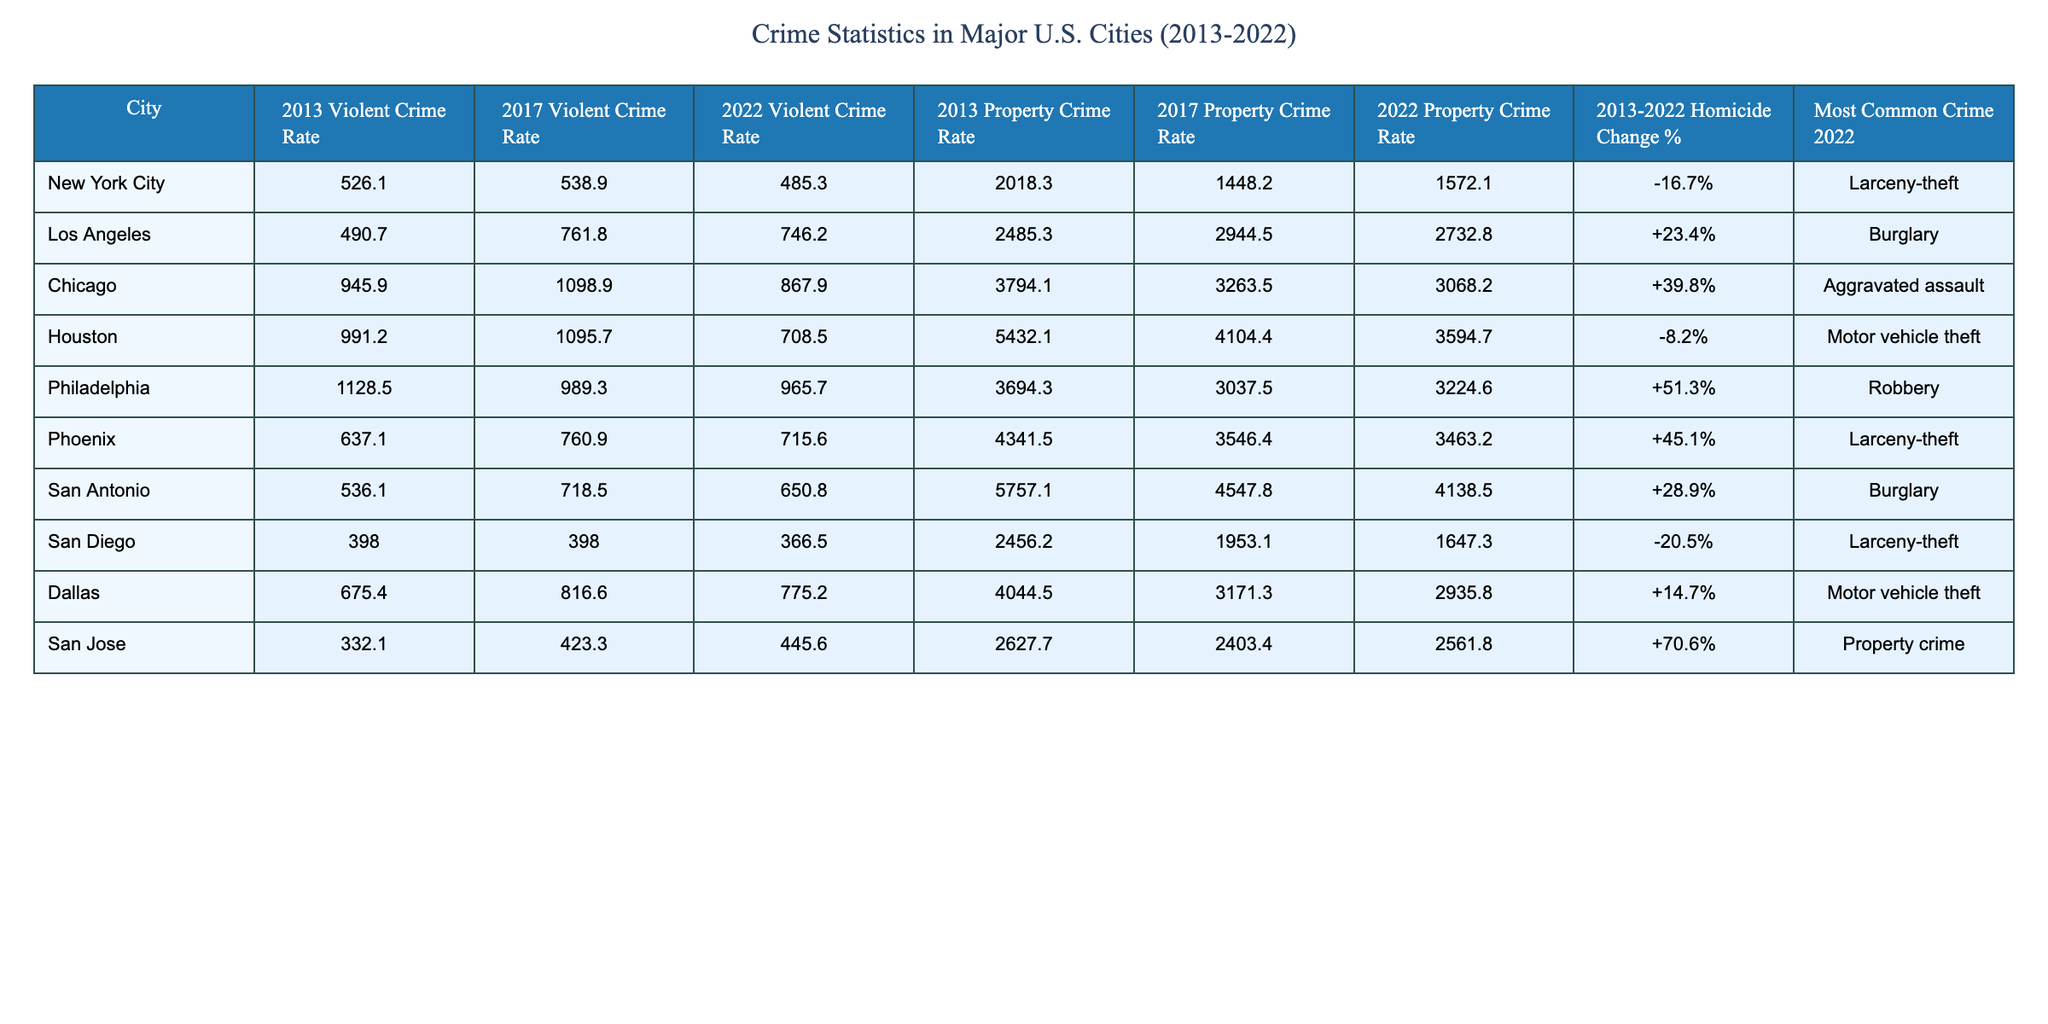What was the violent crime rate in Los Angeles in 2017? The table shows that the violent crime rate for Los Angeles in 2017 is 761.8.
Answer: 761.8 Which city experienced the largest increase in homicide rate from 2013 to 2022? To find this, we compare the "2013-2022 Homicide Change %" for each city. Philadelphia shows a +51.3%, which is the highest among the cities listed.
Answer: Philadelphia What was the most common crime reported in Chicago in 2022? The table indicates that the most common crime reported in Chicago for 2022 is aggravated assault.
Answer: Aggravated assault How much did the property crime rate in San Diego change from 2013 to 2022? The property crime rate in San Diego changed from 2456.2 in 2013 to 1647.3 in 2022, which is a decrease of 808.9.
Answer: Decrease of 808.9 Is the violent crime rate in New York City in 2022 lower than it was in 2013? The violent crime rate in New York City in 2022 is 485.3, which is lower than the rate of 526.1 in 2013, confirming that it is indeed lower.
Answer: Yes What is the average violent crime rate across all cities in 2022? The violent crime rates for 2022 are 485.3, 746.2, 867.9, 708.5, 965.7, 715.6, 650.8, 366.5, and 445.6. The sum of these rates is 4,805.6, and there are 9 cities, so the average is 4,805.6 / 9 = 533.95.
Answer: 533.95 Which city had the highest property crime rate in 2013? The table shows that Houston had the highest property crime rate in 2013 at 5432.1.
Answer: Houston Did San Jose see an increase or decrease in violent crime rate from 2017 to 2022? The violent crime rate in San Jose increased from 423.3 in 2017 to 445.6 in 2022. This indicates an increase in the violent crime rate.
Answer: Increase Which city's property crime rate in 2022 is closest to the property crime rate in 2017 for Los Angeles? The property crime rate for Los Angeles in 2017 is 2944.5, and for 2022 it's 2732.8. The closest value is Phoenix in 2022 with a property crime rate of 3463.2, which is not very close but is the only city that closely follows the trend.
Answer: Phoenix How many city averages would be used to calculate the overall change in homicide rates from 2013-2022? There are 9 cities listed in the table, so the overall change in homicide rates would be calculated using 9 averages.
Answer: 9 